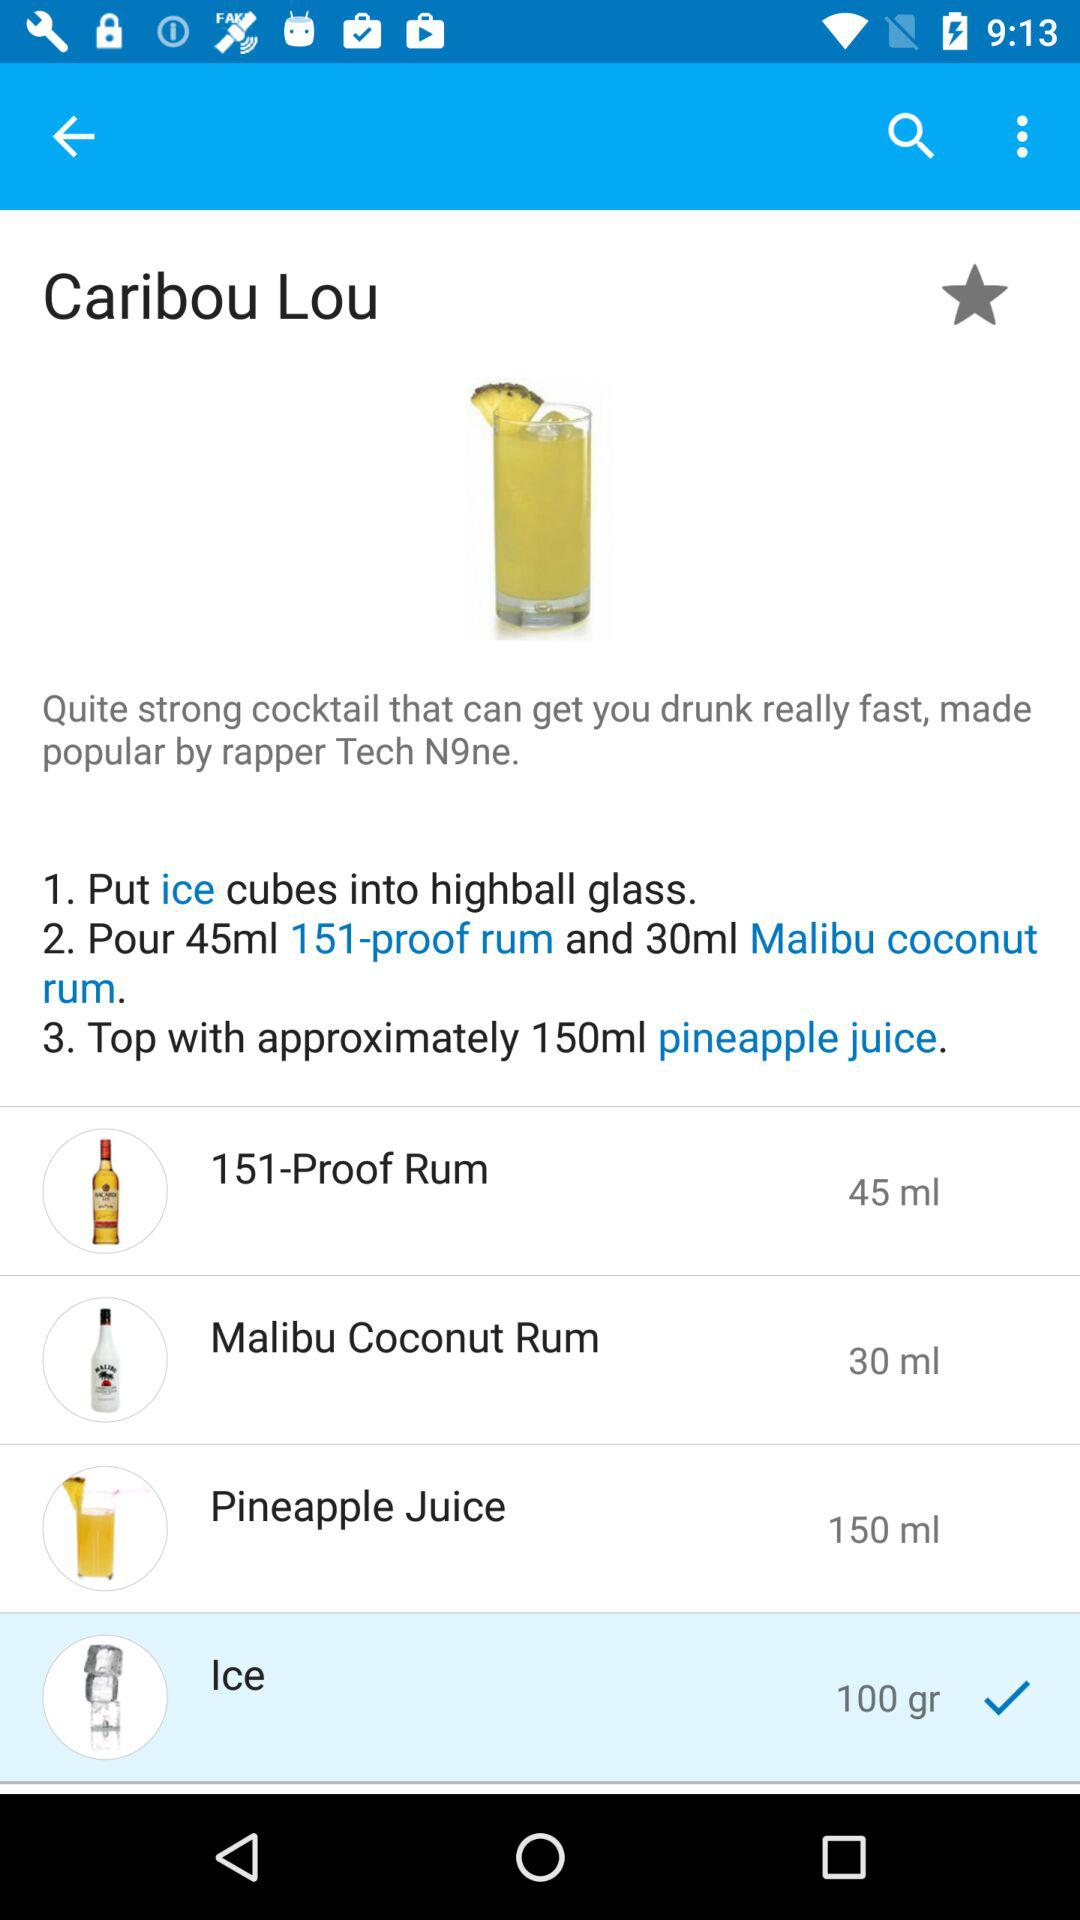What is the name of the product with a volume of 30 ml? The name of the product is "Malibu Coconut Rum". 